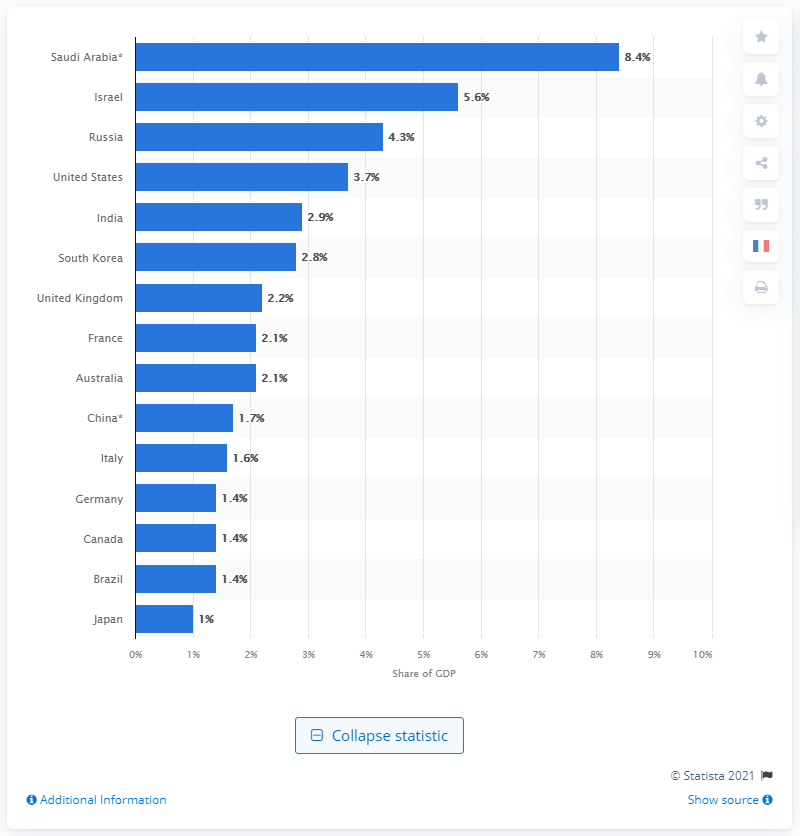List a handful of essential elements in this visual. In 2020, the United States spent approximately 3.7% of its Gross Domestic Product (GDP) on military expenditures. According to recent data, military expenditure accounts for approximately 8.4% of Saudi Arabia's Gross Domestic Product. 